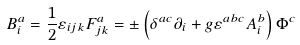Convert formula to latex. <formula><loc_0><loc_0><loc_500><loc_500>B _ { i } ^ { a } = \frac { 1 } { 2 } \varepsilon _ { i j k } F _ { j k } ^ { a } = \pm \left ( \delta ^ { a c } \partial _ { i } + g \varepsilon ^ { a b c } A _ { i } ^ { b } \right ) \Phi ^ { c }</formula> 